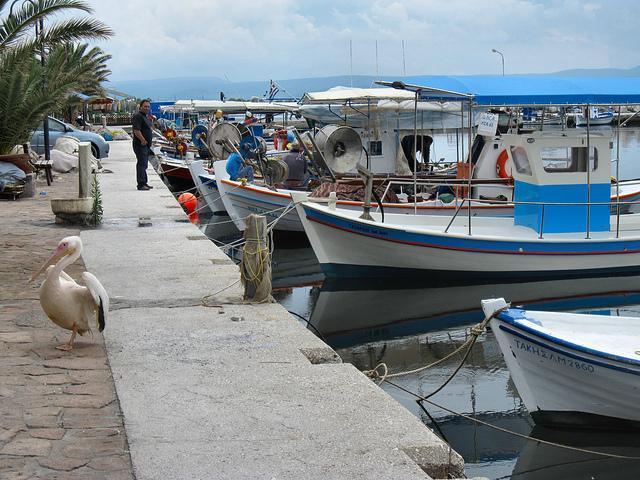What is the name of the large bird?
Select the accurate response from the four choices given to answer the question.
Options: Flamingo, seahawk, stork, pelican. Stork. 